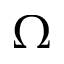Convert formula to latex. <formula><loc_0><loc_0><loc_500><loc_500>\Omega</formula> 